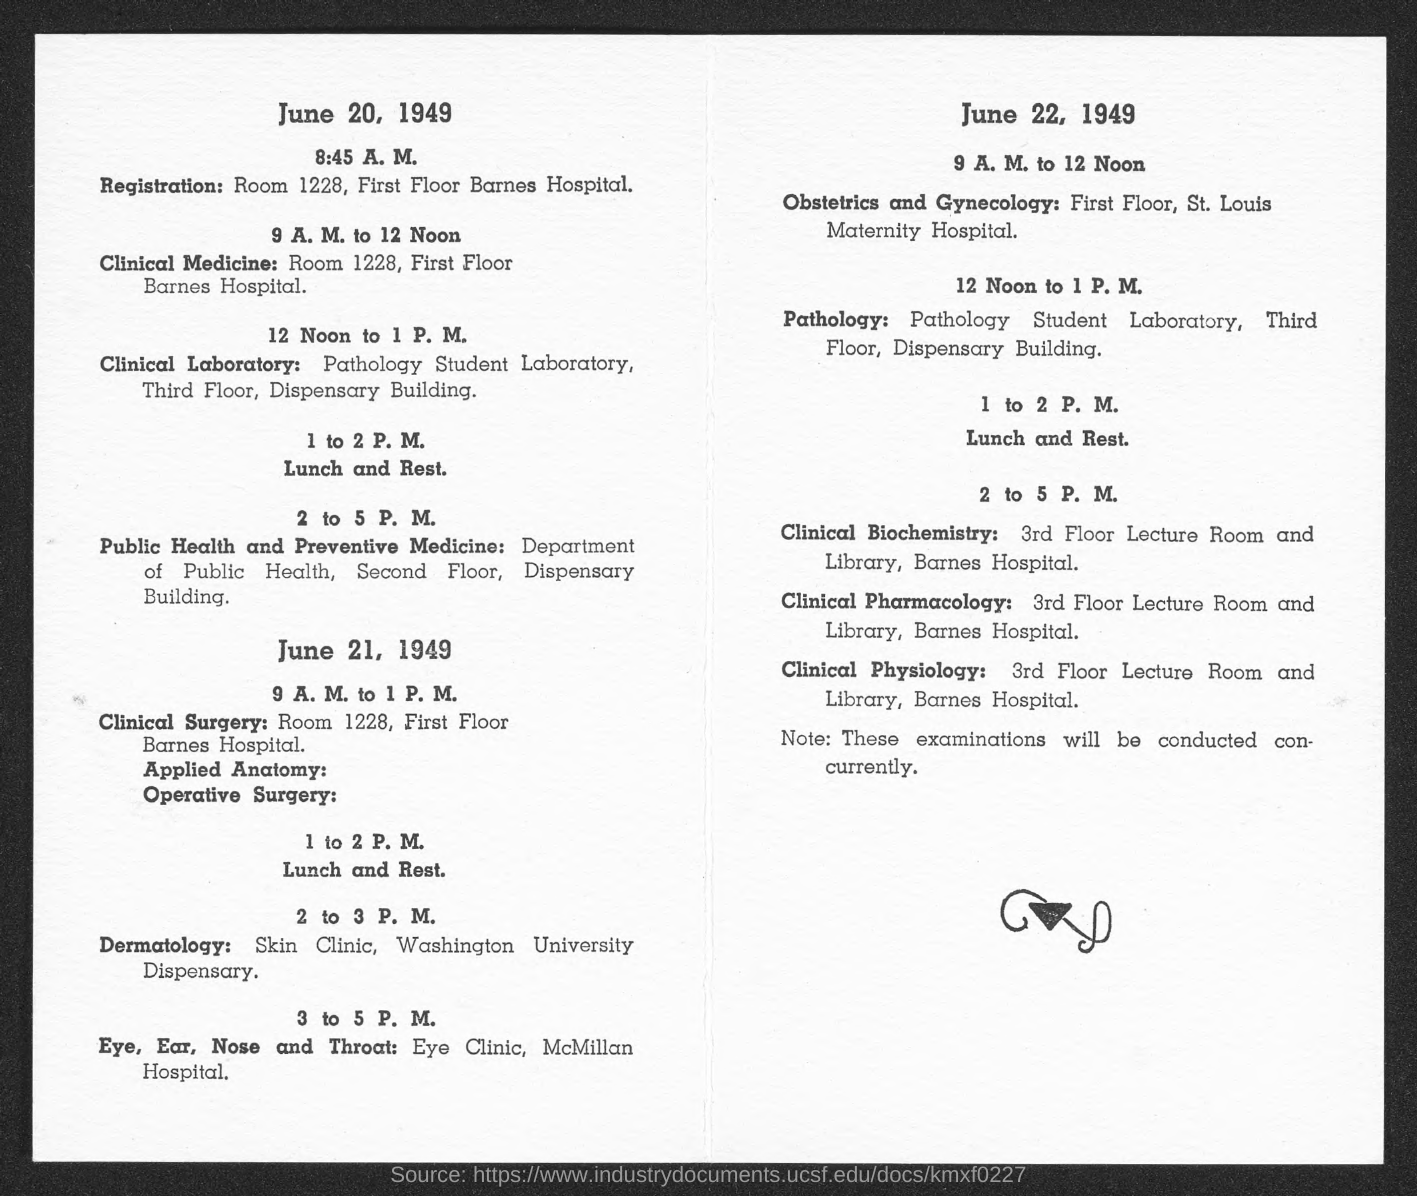Which is the Room No for registration on June 20?
Make the answer very short. Room 1228. 